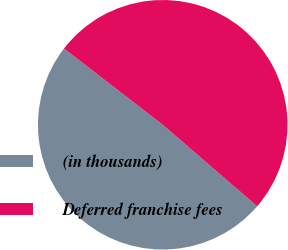Convert chart to OTSL. <chart><loc_0><loc_0><loc_500><loc_500><pie_chart><fcel>(in thousands)<fcel>Deferred franchise fees<nl><fcel>49.13%<fcel>50.87%<nl></chart> 